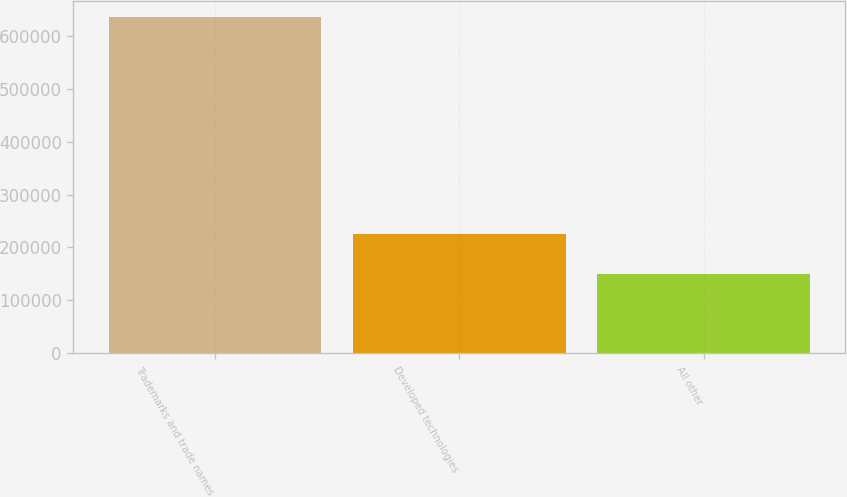Convert chart to OTSL. <chart><loc_0><loc_0><loc_500><loc_500><bar_chart><fcel>Trademarks and trade names<fcel>Developed technologies<fcel>All other<nl><fcel>634387<fcel>225614<fcel>149315<nl></chart> 